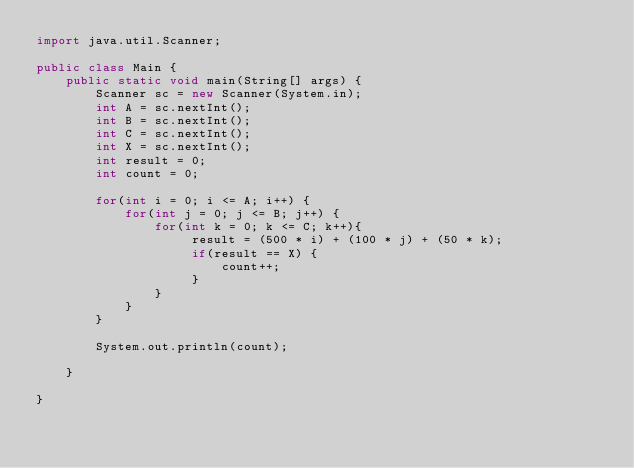<code> <loc_0><loc_0><loc_500><loc_500><_Java_>import java.util.Scanner;

public class Main {
	public static void main(String[] args) {
		Scanner sc = new Scanner(System.in);
		int A = sc.nextInt();
		int B = sc.nextInt();
		int C = sc.nextInt();
		int X = sc.nextInt();
		int result = 0;
		int count = 0;

		for(int i = 0; i <= A; i++) {
			for(int j = 0; j <= B; j++) {
				for(int k = 0; k <= C; k++){
					 result = (500 * i) + (100 * j) + (50 * k);
					 if(result == X) {
						 count++;
					 }
				}
			}
		}

		System.out.println(count);

	}

}</code> 